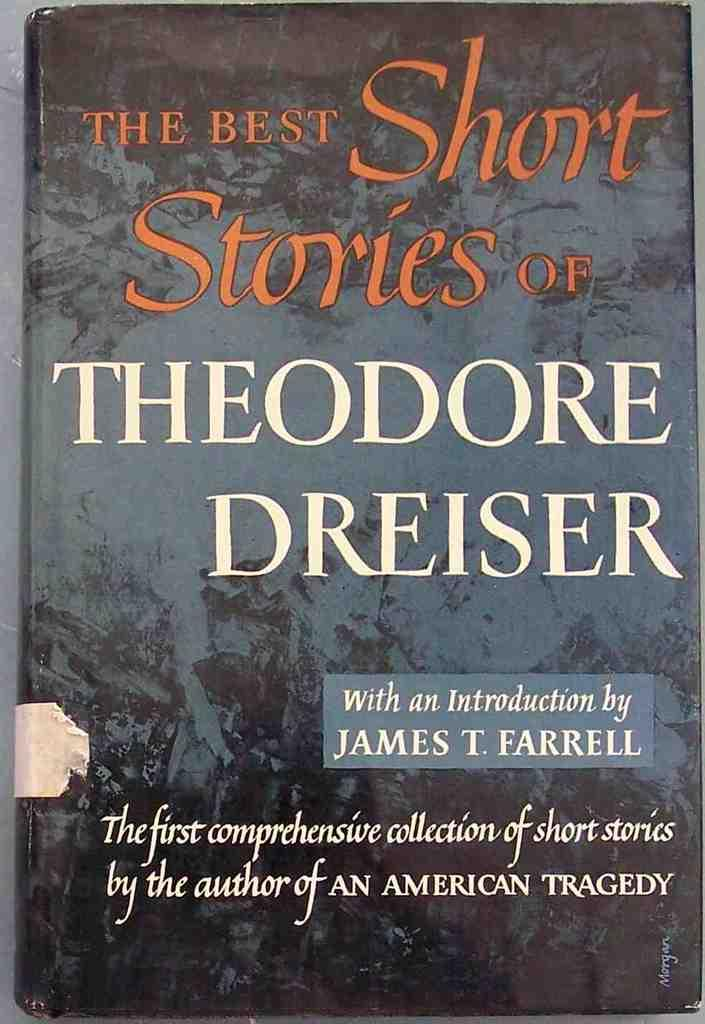<image>
Offer a succinct explanation of the picture presented. The book cover of The Best Short Sories of Theodore Dreiser is shown. 